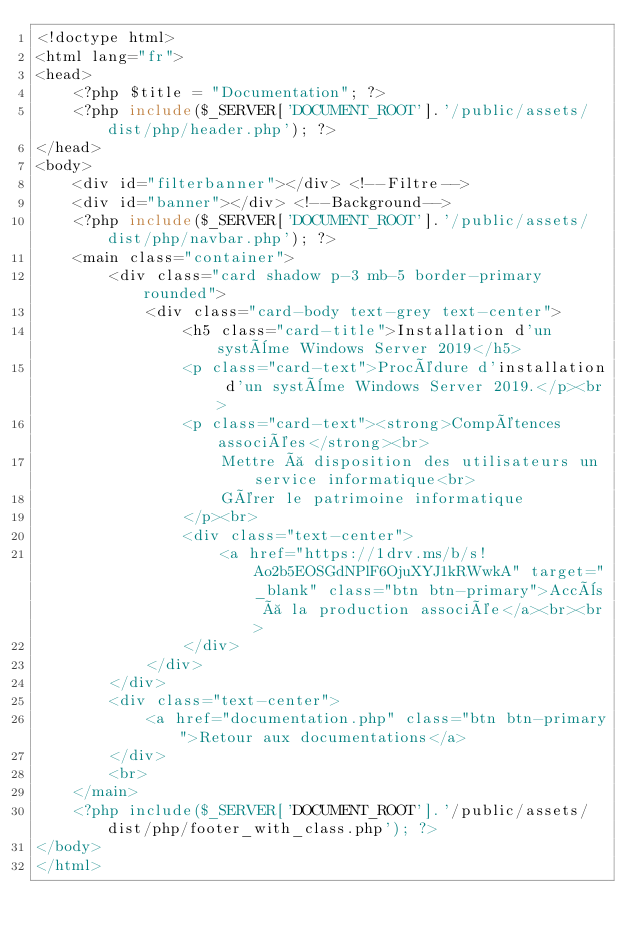Convert code to text. <code><loc_0><loc_0><loc_500><loc_500><_PHP_><!doctype html>
<html lang="fr">
<head>
    <?php $title = "Documentation"; ?>
    <?php include($_SERVER['DOCUMENT_ROOT'].'/public/assets/dist/php/header.php'); ?>
</head>
<body>
    <div id="filterbanner"></div> <!--Filtre-->
    <div id="banner"></div> <!--Background-->
    <?php include($_SERVER['DOCUMENT_ROOT'].'/public/assets/dist/php/navbar.php'); ?>
    <main class="container">
        <div class="card shadow p-3 mb-5 border-primary rounded">
            <div class="card-body text-grey text-center">
                <h5 class="card-title">Installation d'un système Windows Server 2019</h5>
                <p class="card-text">Procédure d'installation d'un système Windows Server 2019.</p><br>
                <p class="card-text"><strong>Compétences associées</strong><br>
                    Mettre à disposition des utilisateurs un service informatique<br>
                    Gérer le patrimoine informatique
                </p><br>
                <div class="text-center">
                    <a href="https://1drv.ms/b/s!Ao2b5EOSGdNPlF6OjuXYJ1kRWwkA" target="_blank" class="btn btn-primary">Accès à la production associée</a><br><br>
                </div>
            </div>
        </div>
        <div class="text-center">
            <a href="documentation.php" class="btn btn-primary">Retour aux documentations</a>
        </div>
        <br>
    </main>
    <?php include($_SERVER['DOCUMENT_ROOT'].'/public/assets/dist/php/footer_with_class.php'); ?>
</body>
</html></code> 